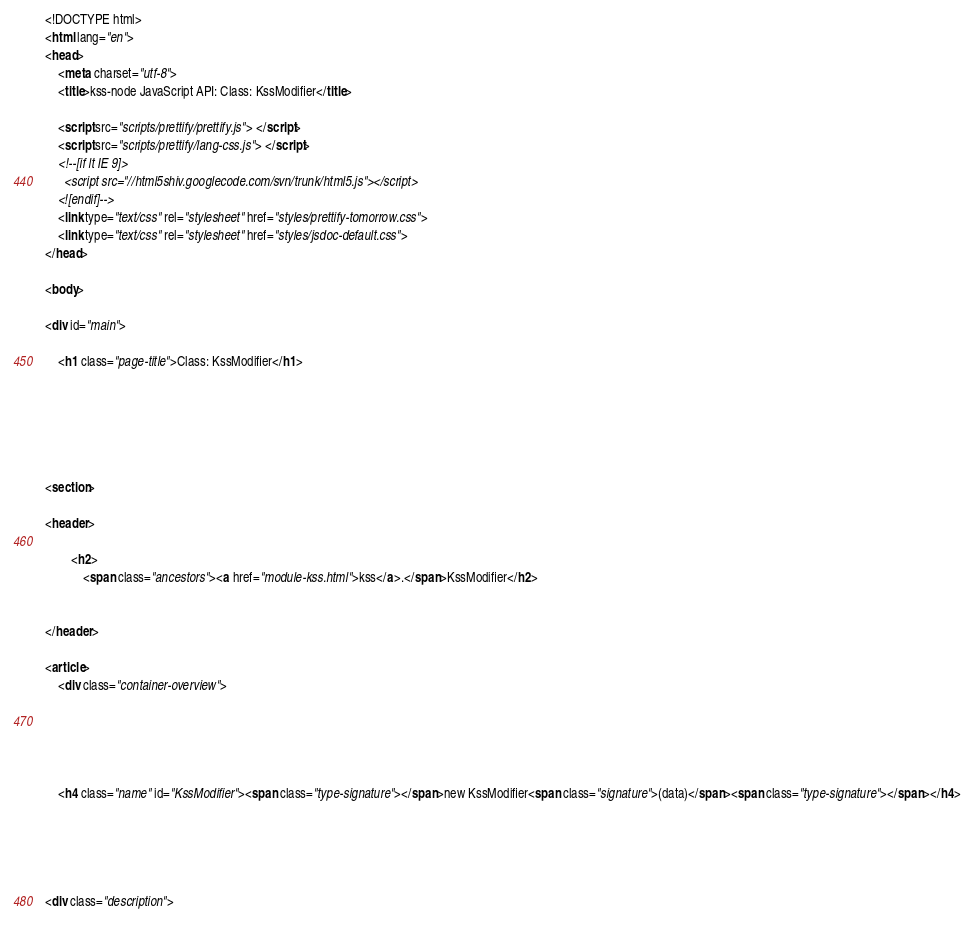<code> <loc_0><loc_0><loc_500><loc_500><_HTML_><!DOCTYPE html>
<html lang="en">
<head>
    <meta charset="utf-8">
    <title>kss-node JavaScript API: Class: KssModifier</title>

    <script src="scripts/prettify/prettify.js"> </script>
    <script src="scripts/prettify/lang-css.js"> </script>
    <!--[if lt IE 9]>
      <script src="//html5shiv.googlecode.com/svn/trunk/html5.js"></script>
    <![endif]-->
    <link type="text/css" rel="stylesheet" href="styles/prettify-tomorrow.css">
    <link type="text/css" rel="stylesheet" href="styles/jsdoc-default.css">
</head>

<body>

<div id="main">

    <h1 class="page-title">Class: KssModifier</h1>

    




<section>

<header>
    
        <h2>
            <span class="ancestors"><a href="module-kss.html">kss</a>.</span>KssModifier</h2>
        
    
</header>

<article>
    <div class="container-overview">
    
        

    

    <h4 class="name" id="KssModifier"><span class="type-signature"></span>new KssModifier<span class="signature">(data)</span><span class="type-signature"></span></h4>

    



<div class="description"></code> 